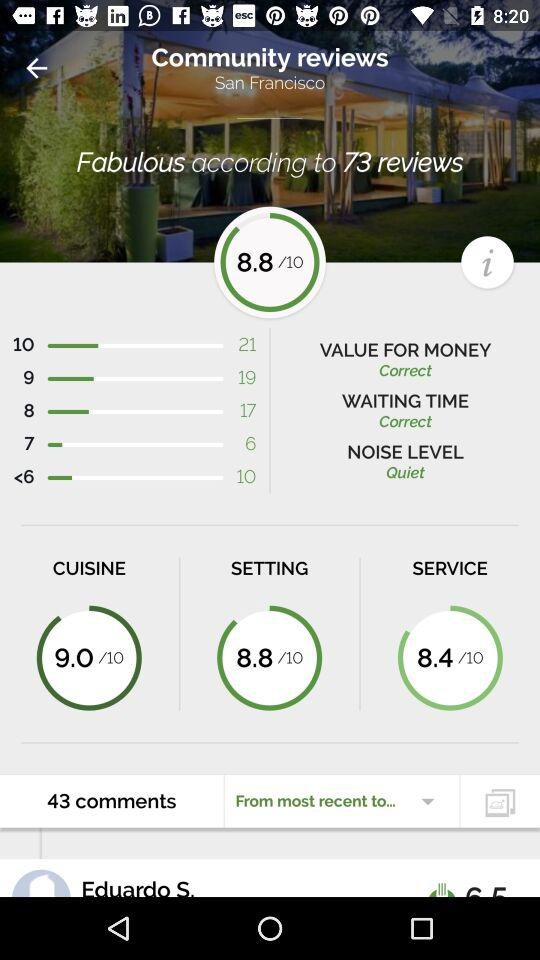What is the average rating of this restaurant?
Answer the question using a single word or phrase. 8.8 